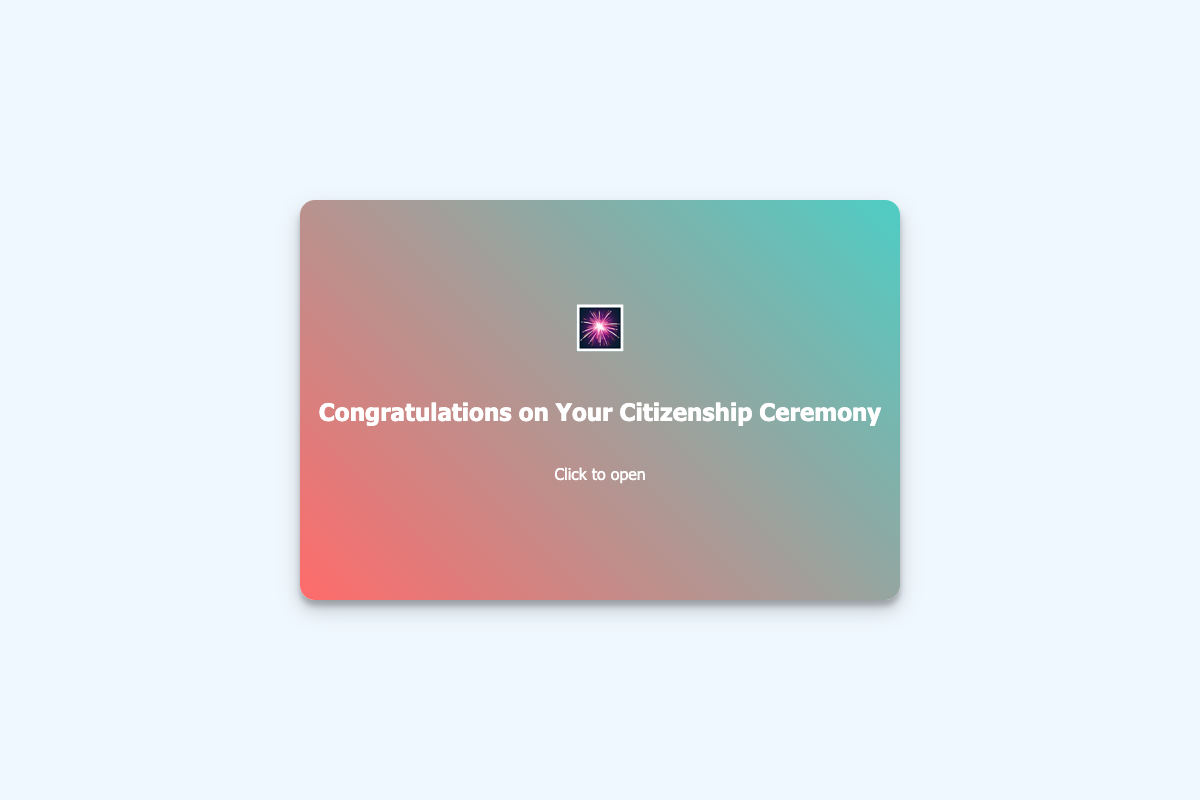What is the main theme of the card? The card congratulates the recipient for becoming a U.S. citizen, highlighting a significant life milestone.
Answer: Congratulations on Your Citizenship Ceremony Who is the card directed to? The card is addressed to individuals who have recently obtained U.S. citizenship.
Answer: You What visual elements are present on the card? The card features celebratory designs such as fireworks and the American flag that symbolize the occasion of citizenship.
Answer: Fireworks and American flag What greeting is displayed inside the card? The card includes a warm and welcoming message for the new citizen, offering congratulations.
Answer: Welcome to the American Family! What profession does the card sender identify with? The card sender identifies as an immigration lawyer who supports new U.S. citizens in their journey.
Answer: Reformist Immigration Lawyer 